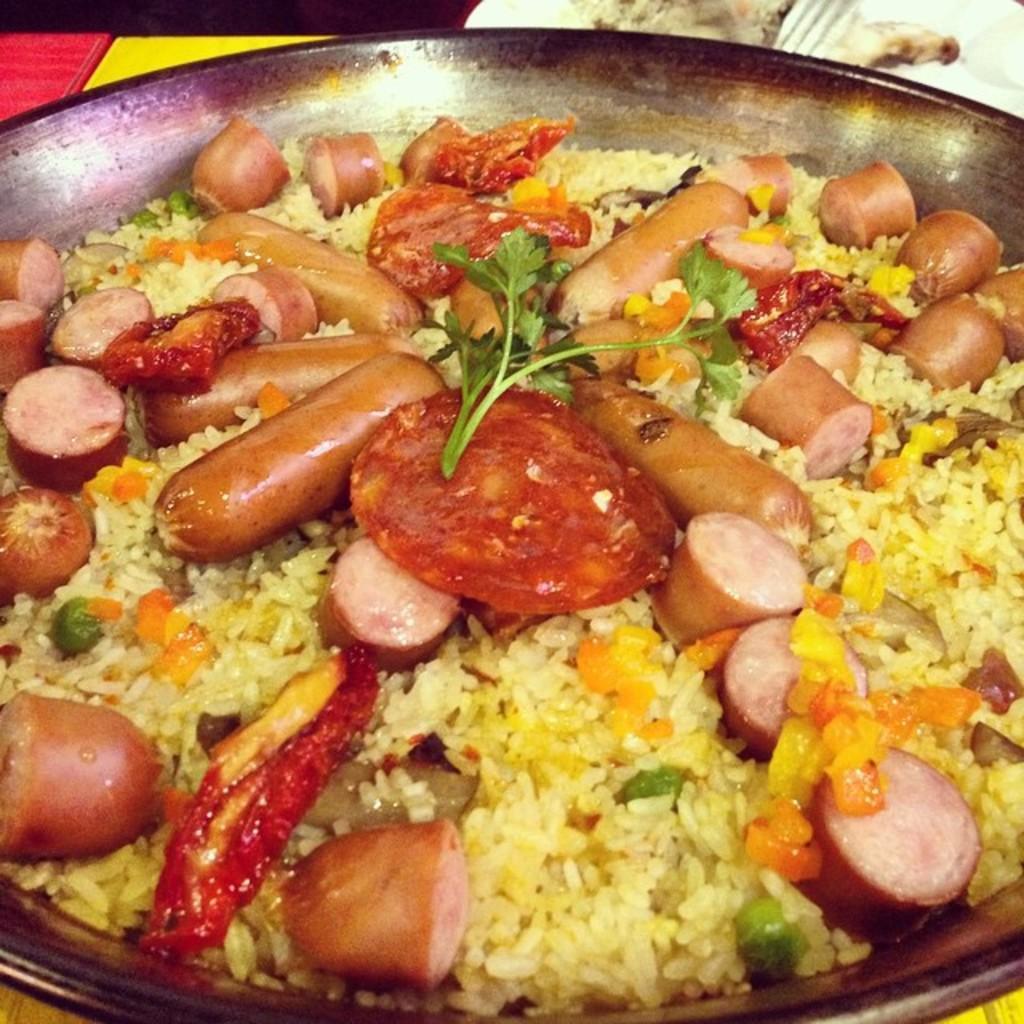Could you give a brief overview of what you see in this image? In this image we can see the rice and vegetables in the pan. 